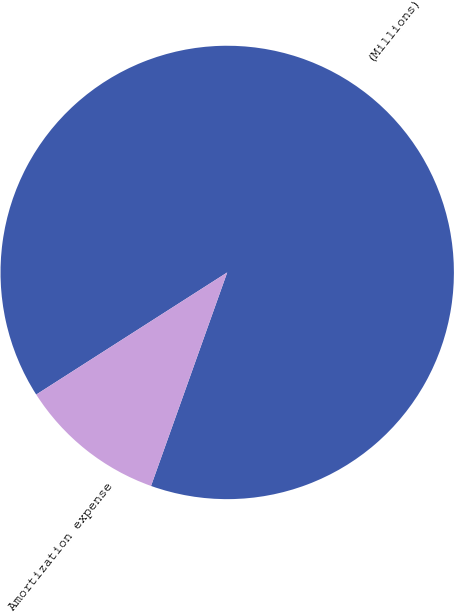Convert chart. <chart><loc_0><loc_0><loc_500><loc_500><pie_chart><fcel>(Millions)<fcel>Amortization expense<nl><fcel>89.51%<fcel>10.49%<nl></chart> 